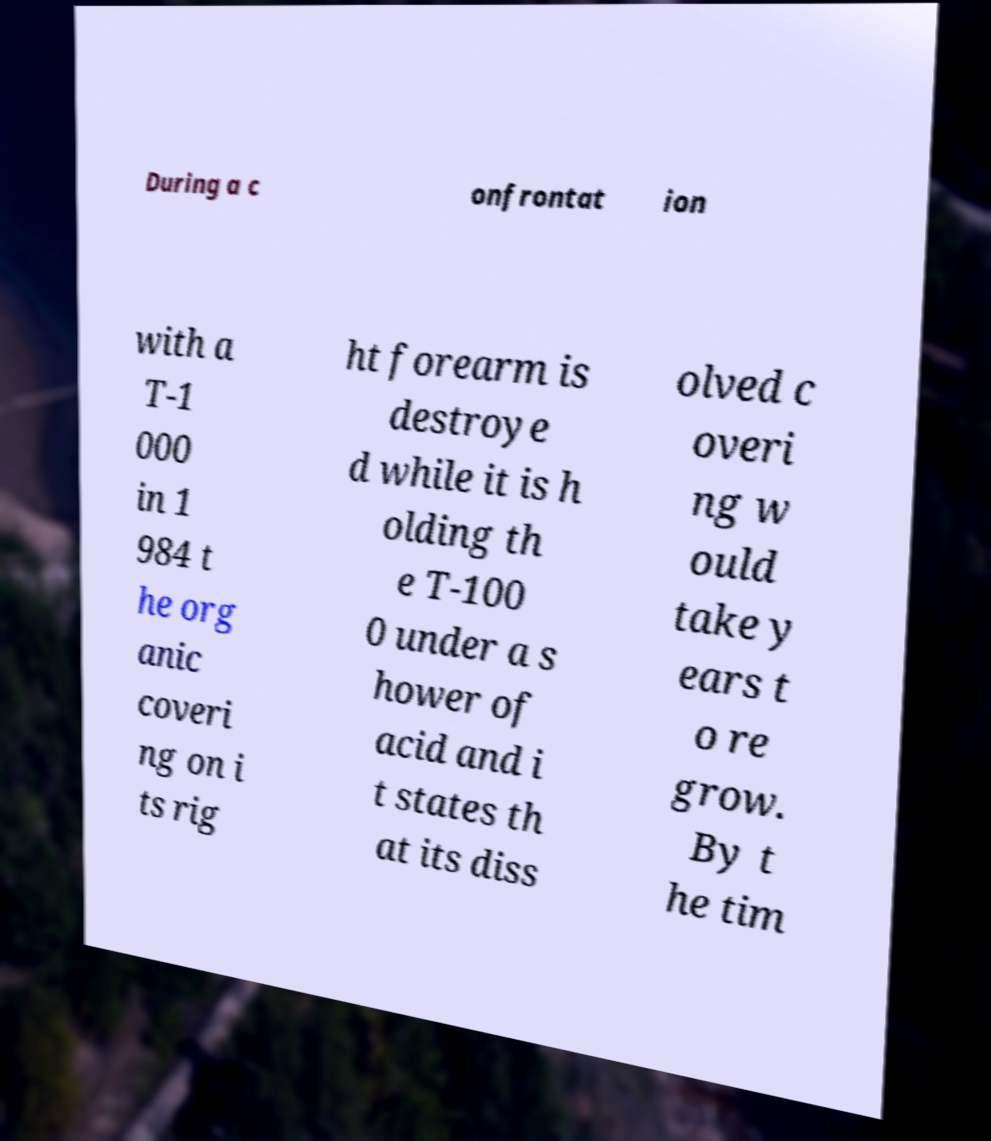Could you extract and type out the text from this image? During a c onfrontat ion with a T-1 000 in 1 984 t he org anic coveri ng on i ts rig ht forearm is destroye d while it is h olding th e T-100 0 under a s hower of acid and i t states th at its diss olved c overi ng w ould take y ears t o re grow. By t he tim 